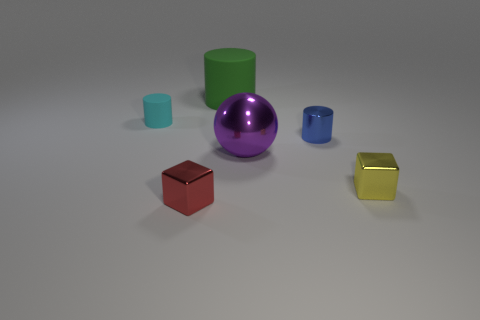Is the number of small cylinders that are right of the purple shiny object greater than the number of yellow shiny blocks left of the big matte thing?
Your answer should be very brief. Yes. Are there any other rubber things of the same shape as the small blue thing?
Your response must be concise. Yes. There is a cyan cylinder on the left side of the yellow metal block; is its size the same as the small blue metallic object?
Your response must be concise. Yes. Are any blue metallic objects visible?
Your answer should be very brief. Yes. How many things are small rubber cylinders behind the small blue shiny object or small cyan matte cylinders?
Give a very brief answer. 1. There is a ball; is its color the same as the small metal object behind the large purple metal object?
Offer a very short reply. No. Is there a ball that has the same size as the blue object?
Offer a very short reply. No. There is a thing that is behind the matte cylinder on the left side of the big green object; what is it made of?
Your response must be concise. Rubber. How many small metal blocks have the same color as the big sphere?
Your answer should be compact. 0. There is a cyan object that is the same material as the large green object; what is its shape?
Your response must be concise. Cylinder. 